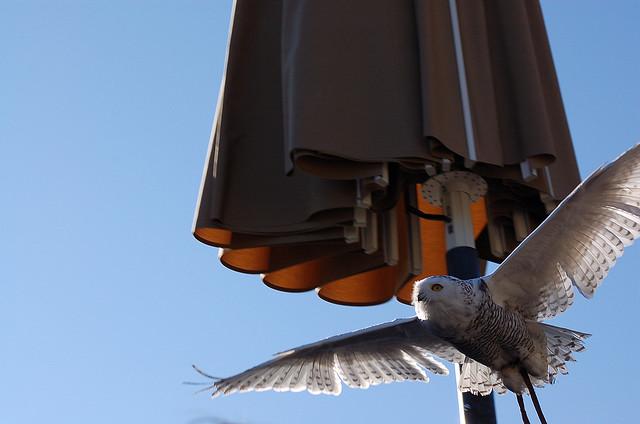What is behind the owl?
Write a very short answer. Umbrella. Is this animal a raptor?
Be succinct. No. What color is the umbrella?
Keep it brief. Brown. 